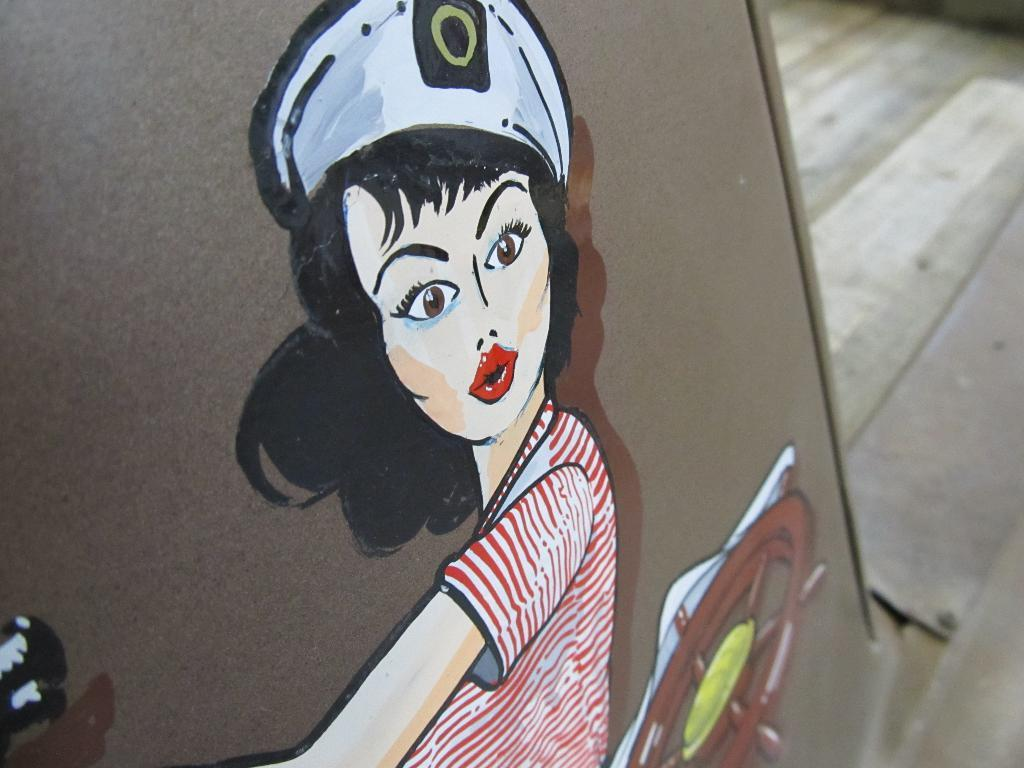Who is the main subject in the image? There is a girl in the image. What is the girl doing in the image? The girl is painting on a brown board. What color is the girl's shirt? The girl is wearing a red shirt. What type of headwear is the girl wearing? The girl is wearing a white cap. What type of loaf is the girl using to paint on the brown board? There is no loaf present in the image; the girl is using a paintbrush or similar tool to paint on the brown board. 